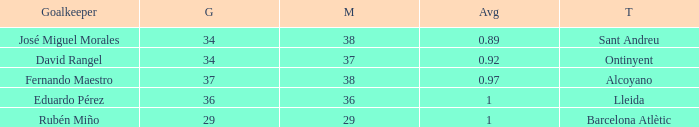What is the highest Average, when Goals is "34", and when Matches is less than 37? None. 